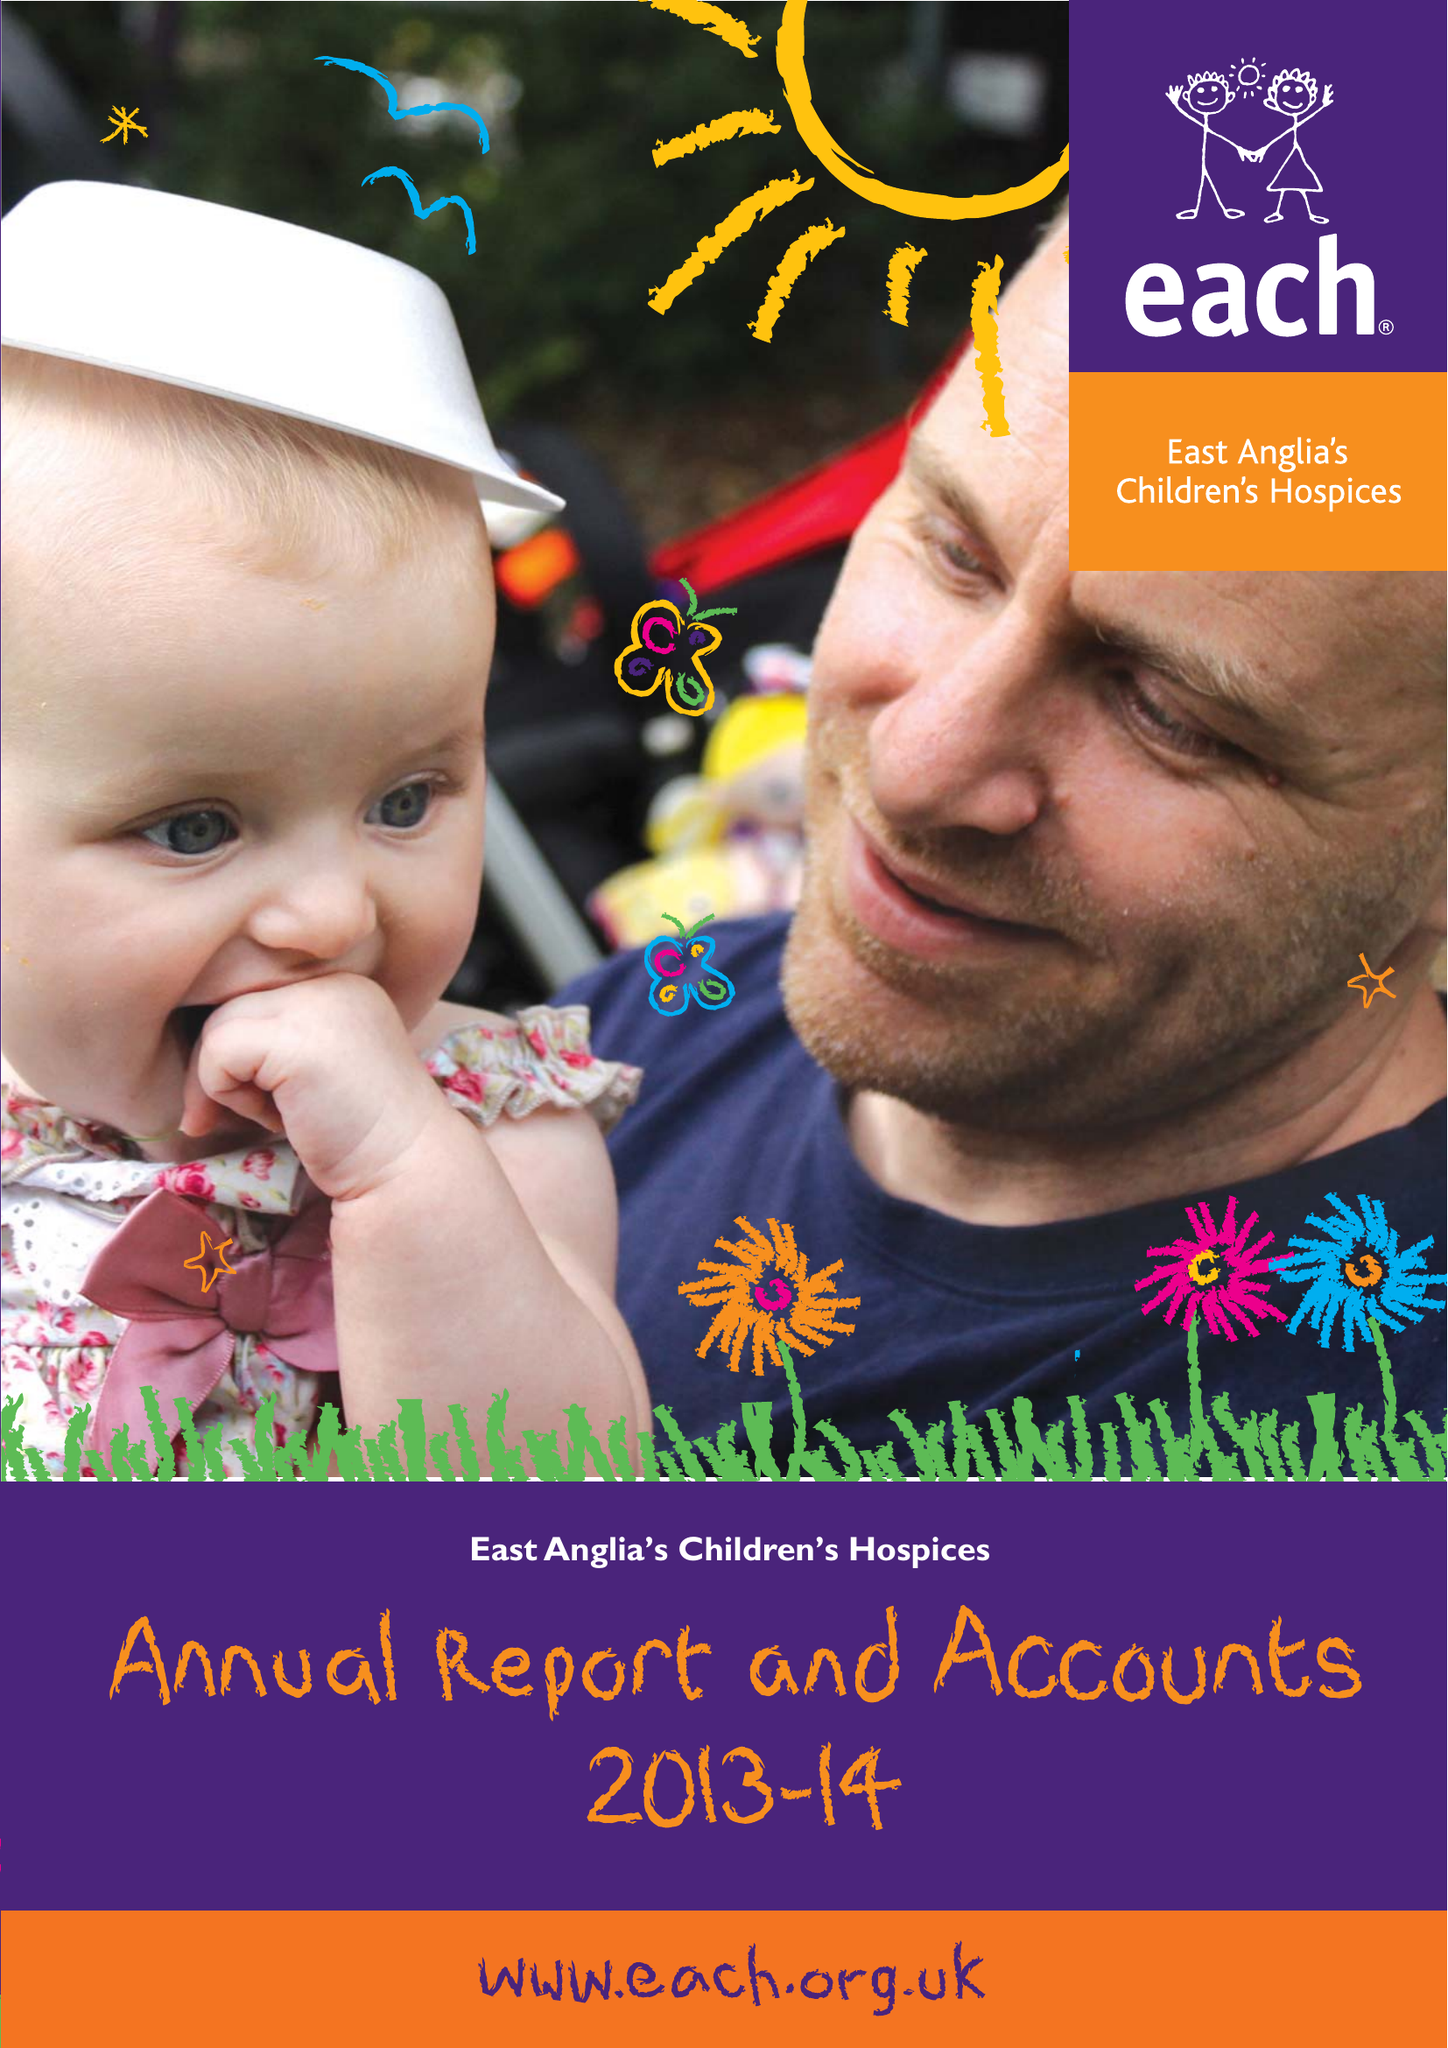What is the value for the address__street_line?
Answer the question using a single word or phrase. 42 HIGH STREET 